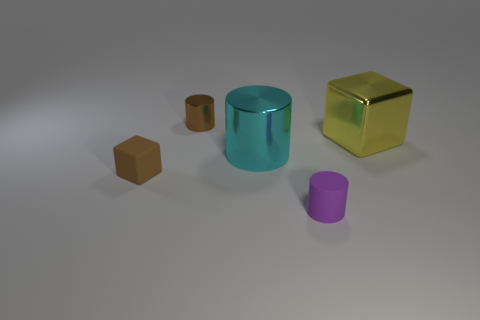The small block is what color? The small block on the left of the image exhibits a rich, earthy brown hue, reminiscent of clay or autumn leaves. 